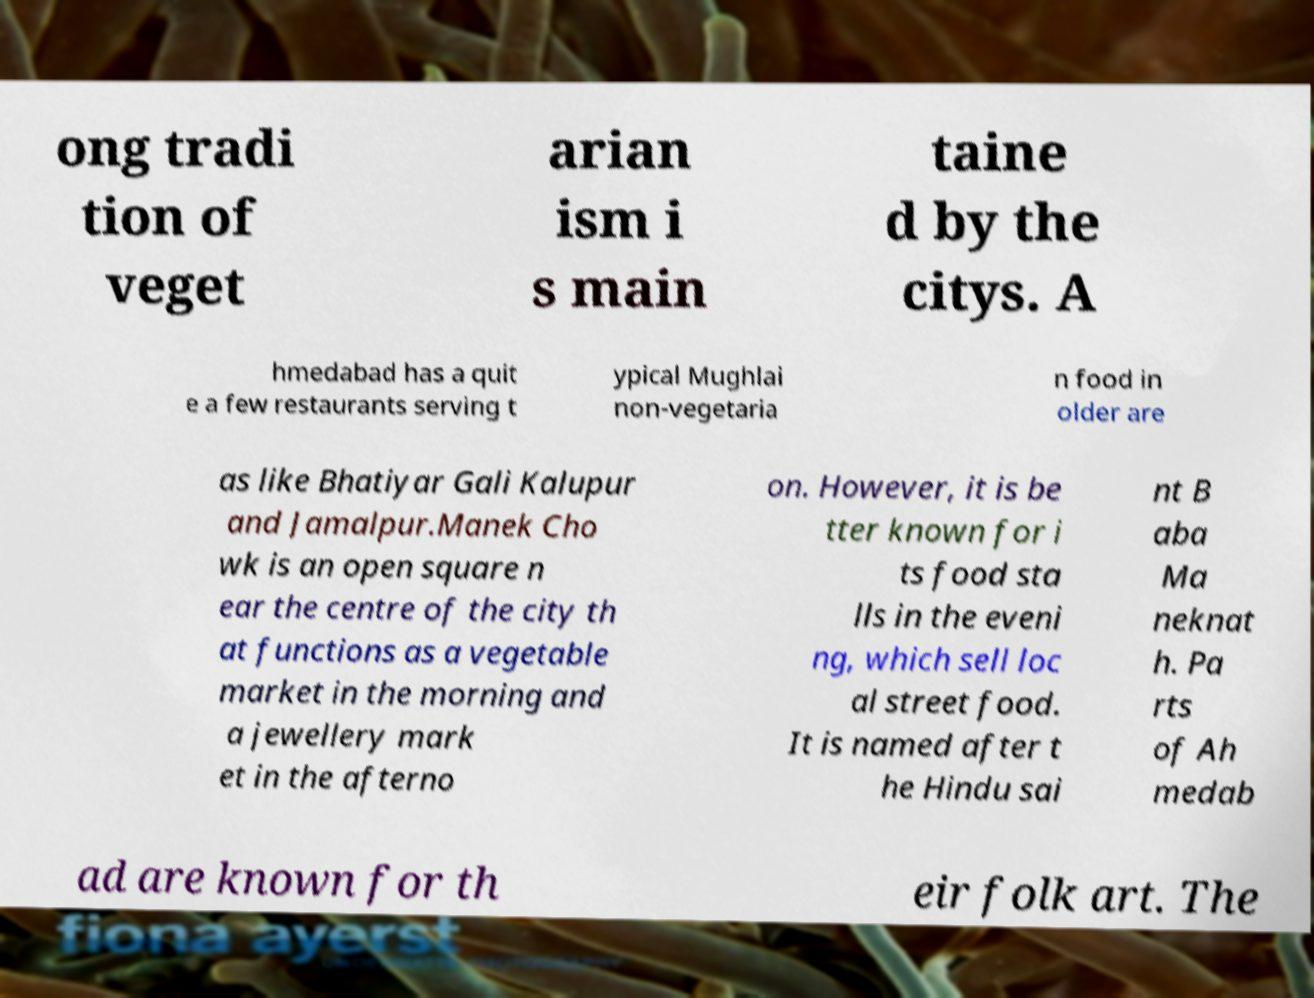Could you extract and type out the text from this image? ong tradi tion of veget arian ism i s main taine d by the citys. A hmedabad has a quit e a few restaurants serving t ypical Mughlai non-vegetaria n food in older are as like Bhatiyar Gali Kalupur and Jamalpur.Manek Cho wk is an open square n ear the centre of the city th at functions as a vegetable market in the morning and a jewellery mark et in the afterno on. However, it is be tter known for i ts food sta lls in the eveni ng, which sell loc al street food. It is named after t he Hindu sai nt B aba Ma neknat h. Pa rts of Ah medab ad are known for th eir folk art. The 